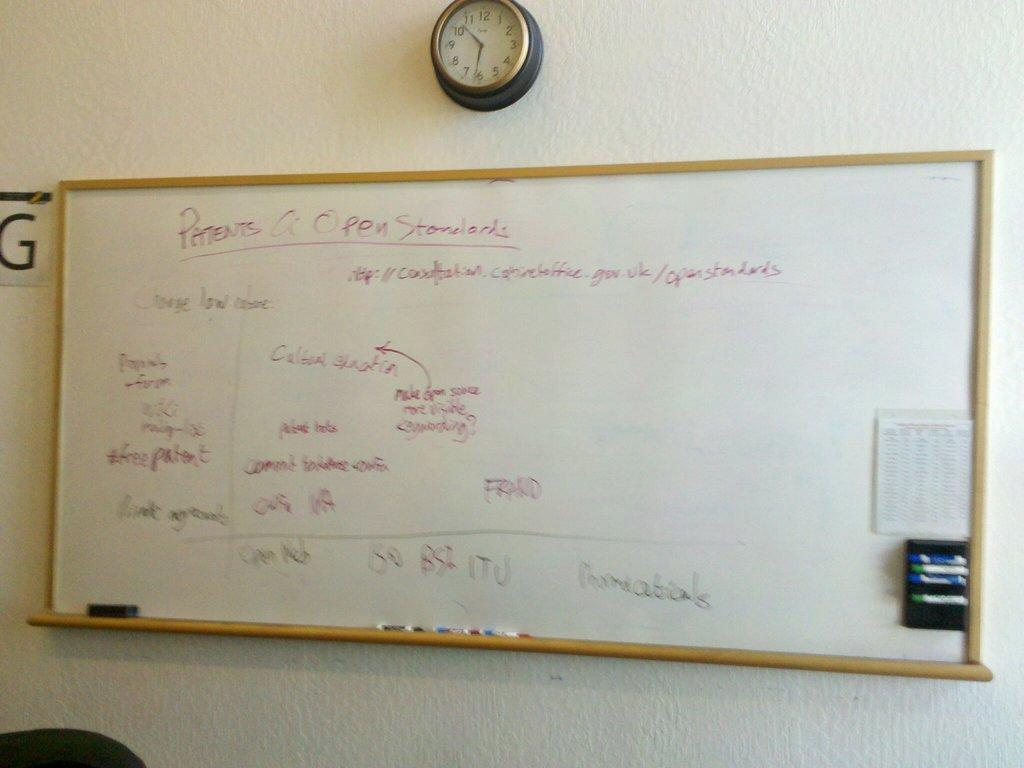<image>
Create a compact narrative representing the image presented. A whiteboard mounted on a wall about Patents. 